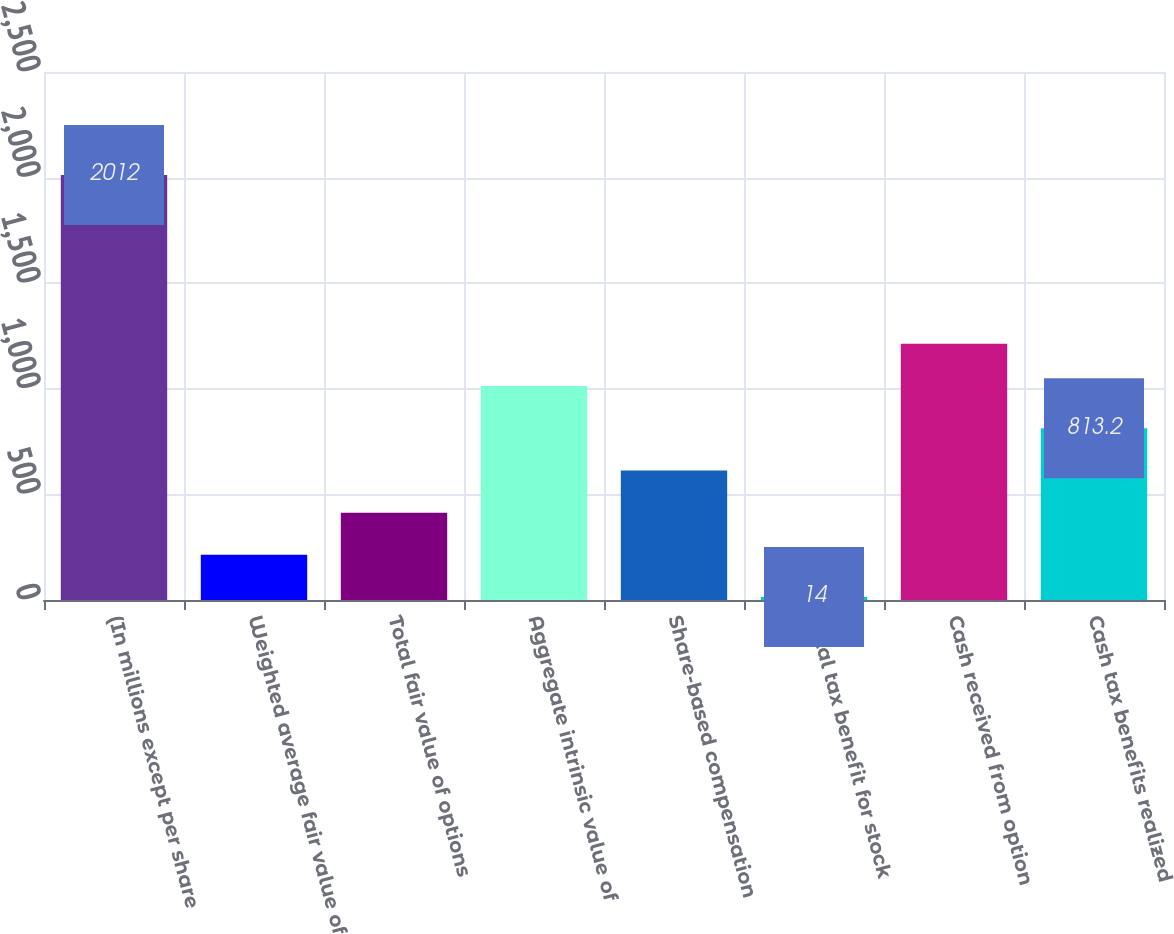Convert chart. <chart><loc_0><loc_0><loc_500><loc_500><bar_chart><fcel>(In millions except per share<fcel>Weighted average fair value of<fcel>Total fair value of options<fcel>Aggregate intrinsic value of<fcel>Share-based compensation<fcel>Total tax benefit for stock<fcel>Cash received from option<fcel>Cash tax benefits realized<nl><fcel>2012<fcel>213.8<fcel>413.6<fcel>1013<fcel>613.4<fcel>14<fcel>1212.8<fcel>813.2<nl></chart> 